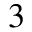<formula> <loc_0><loc_0><loc_500><loc_500>^ { 3 }</formula> 